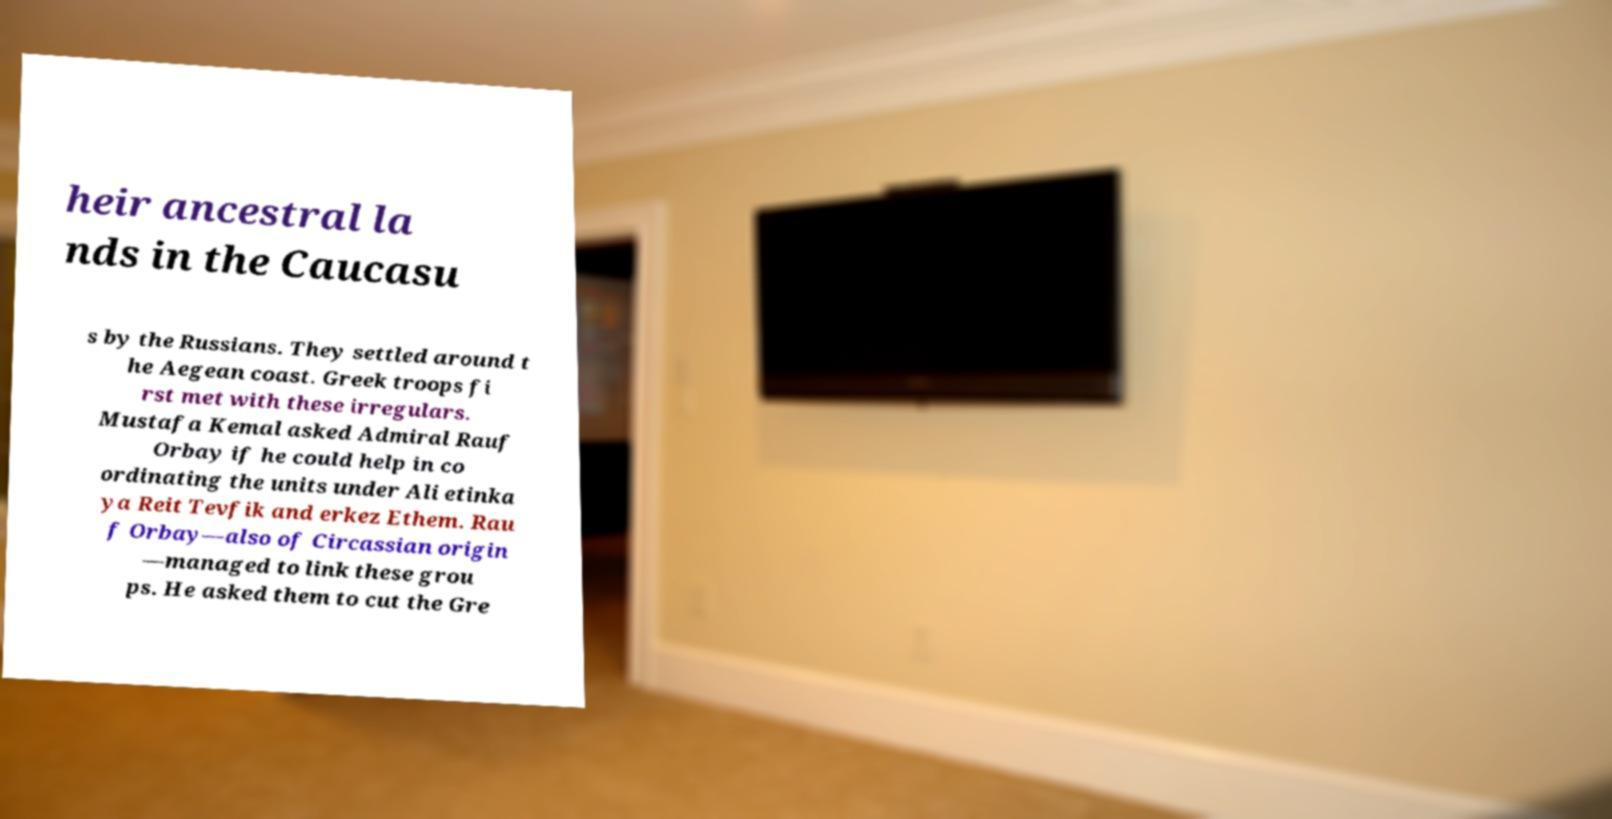Please identify and transcribe the text found in this image. heir ancestral la nds in the Caucasu s by the Russians. They settled around t he Aegean coast. Greek troops fi rst met with these irregulars. Mustafa Kemal asked Admiral Rauf Orbay if he could help in co ordinating the units under Ali etinka ya Reit Tevfik and erkez Ethem. Rau f Orbay—also of Circassian origin —managed to link these grou ps. He asked them to cut the Gre 